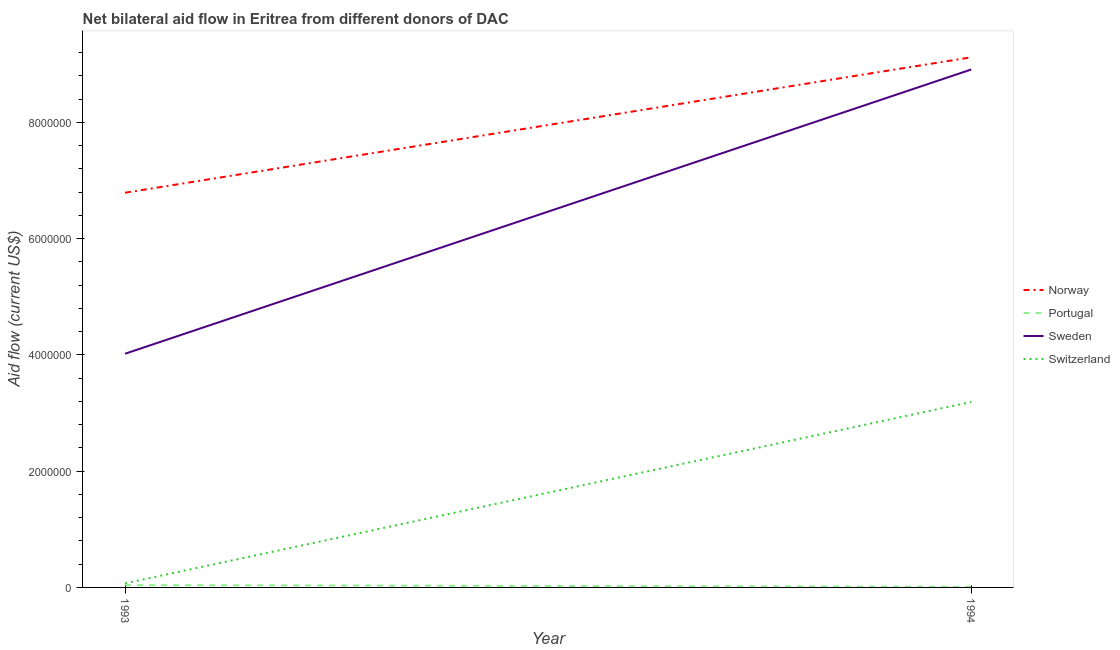How many different coloured lines are there?
Make the answer very short. 4. Does the line corresponding to amount of aid given by norway intersect with the line corresponding to amount of aid given by portugal?
Keep it short and to the point. No. What is the amount of aid given by switzerland in 1994?
Offer a very short reply. 3.19e+06. Across all years, what is the maximum amount of aid given by norway?
Your response must be concise. 9.12e+06. Across all years, what is the minimum amount of aid given by sweden?
Give a very brief answer. 4.02e+06. In which year was the amount of aid given by sweden maximum?
Your answer should be compact. 1994. What is the total amount of aid given by portugal in the graph?
Your answer should be very brief. 5.00e+04. What is the difference between the amount of aid given by switzerland in 1993 and that in 1994?
Provide a succinct answer. -3.12e+06. What is the difference between the amount of aid given by portugal in 1993 and the amount of aid given by sweden in 1994?
Make the answer very short. -8.87e+06. What is the average amount of aid given by norway per year?
Offer a very short reply. 7.96e+06. In the year 1993, what is the difference between the amount of aid given by portugal and amount of aid given by sweden?
Your response must be concise. -3.98e+06. In how many years, is the amount of aid given by portugal greater than 5600000 US$?
Offer a very short reply. 0. What is the ratio of the amount of aid given by switzerland in 1993 to that in 1994?
Give a very brief answer. 0.02. Is the amount of aid given by norway strictly greater than the amount of aid given by switzerland over the years?
Give a very brief answer. Yes. How many lines are there?
Your answer should be very brief. 4. Does the graph contain any zero values?
Offer a very short reply. No. Does the graph contain grids?
Offer a very short reply. No. Where does the legend appear in the graph?
Your answer should be very brief. Center right. How are the legend labels stacked?
Your response must be concise. Vertical. What is the title of the graph?
Offer a very short reply. Net bilateral aid flow in Eritrea from different donors of DAC. Does "UNTA" appear as one of the legend labels in the graph?
Make the answer very short. No. What is the label or title of the X-axis?
Your answer should be very brief. Year. What is the label or title of the Y-axis?
Give a very brief answer. Aid flow (current US$). What is the Aid flow (current US$) in Norway in 1993?
Provide a short and direct response. 6.79e+06. What is the Aid flow (current US$) in Portugal in 1993?
Make the answer very short. 4.00e+04. What is the Aid flow (current US$) in Sweden in 1993?
Give a very brief answer. 4.02e+06. What is the Aid flow (current US$) in Norway in 1994?
Your response must be concise. 9.12e+06. What is the Aid flow (current US$) of Portugal in 1994?
Your answer should be very brief. 10000. What is the Aid flow (current US$) of Sweden in 1994?
Offer a very short reply. 8.91e+06. What is the Aid flow (current US$) of Switzerland in 1994?
Offer a terse response. 3.19e+06. Across all years, what is the maximum Aid flow (current US$) of Norway?
Your answer should be very brief. 9.12e+06. Across all years, what is the maximum Aid flow (current US$) of Sweden?
Provide a short and direct response. 8.91e+06. Across all years, what is the maximum Aid flow (current US$) in Switzerland?
Keep it short and to the point. 3.19e+06. Across all years, what is the minimum Aid flow (current US$) in Norway?
Ensure brevity in your answer.  6.79e+06. Across all years, what is the minimum Aid flow (current US$) of Sweden?
Offer a very short reply. 4.02e+06. Across all years, what is the minimum Aid flow (current US$) in Switzerland?
Make the answer very short. 7.00e+04. What is the total Aid flow (current US$) in Norway in the graph?
Offer a very short reply. 1.59e+07. What is the total Aid flow (current US$) in Portugal in the graph?
Your response must be concise. 5.00e+04. What is the total Aid flow (current US$) of Sweden in the graph?
Keep it short and to the point. 1.29e+07. What is the total Aid flow (current US$) in Switzerland in the graph?
Provide a short and direct response. 3.26e+06. What is the difference between the Aid flow (current US$) of Norway in 1993 and that in 1994?
Give a very brief answer. -2.33e+06. What is the difference between the Aid flow (current US$) of Sweden in 1993 and that in 1994?
Keep it short and to the point. -4.89e+06. What is the difference between the Aid flow (current US$) of Switzerland in 1993 and that in 1994?
Offer a very short reply. -3.12e+06. What is the difference between the Aid flow (current US$) of Norway in 1993 and the Aid flow (current US$) of Portugal in 1994?
Your answer should be compact. 6.78e+06. What is the difference between the Aid flow (current US$) of Norway in 1993 and the Aid flow (current US$) of Sweden in 1994?
Give a very brief answer. -2.12e+06. What is the difference between the Aid flow (current US$) in Norway in 1993 and the Aid flow (current US$) in Switzerland in 1994?
Your answer should be very brief. 3.60e+06. What is the difference between the Aid flow (current US$) in Portugal in 1993 and the Aid flow (current US$) in Sweden in 1994?
Keep it short and to the point. -8.87e+06. What is the difference between the Aid flow (current US$) in Portugal in 1993 and the Aid flow (current US$) in Switzerland in 1994?
Make the answer very short. -3.15e+06. What is the difference between the Aid flow (current US$) of Sweden in 1993 and the Aid flow (current US$) of Switzerland in 1994?
Keep it short and to the point. 8.30e+05. What is the average Aid flow (current US$) in Norway per year?
Offer a terse response. 7.96e+06. What is the average Aid flow (current US$) in Portugal per year?
Your answer should be compact. 2.50e+04. What is the average Aid flow (current US$) in Sweden per year?
Give a very brief answer. 6.46e+06. What is the average Aid flow (current US$) in Switzerland per year?
Offer a terse response. 1.63e+06. In the year 1993, what is the difference between the Aid flow (current US$) in Norway and Aid flow (current US$) in Portugal?
Offer a very short reply. 6.75e+06. In the year 1993, what is the difference between the Aid flow (current US$) of Norway and Aid flow (current US$) of Sweden?
Keep it short and to the point. 2.77e+06. In the year 1993, what is the difference between the Aid flow (current US$) in Norway and Aid flow (current US$) in Switzerland?
Your answer should be very brief. 6.72e+06. In the year 1993, what is the difference between the Aid flow (current US$) in Portugal and Aid flow (current US$) in Sweden?
Your answer should be compact. -3.98e+06. In the year 1993, what is the difference between the Aid flow (current US$) of Portugal and Aid flow (current US$) of Switzerland?
Give a very brief answer. -3.00e+04. In the year 1993, what is the difference between the Aid flow (current US$) in Sweden and Aid flow (current US$) in Switzerland?
Your response must be concise. 3.95e+06. In the year 1994, what is the difference between the Aid flow (current US$) of Norway and Aid flow (current US$) of Portugal?
Your answer should be compact. 9.11e+06. In the year 1994, what is the difference between the Aid flow (current US$) of Norway and Aid flow (current US$) of Switzerland?
Your answer should be compact. 5.93e+06. In the year 1994, what is the difference between the Aid flow (current US$) in Portugal and Aid flow (current US$) in Sweden?
Provide a succinct answer. -8.90e+06. In the year 1994, what is the difference between the Aid flow (current US$) of Portugal and Aid flow (current US$) of Switzerland?
Provide a succinct answer. -3.18e+06. In the year 1994, what is the difference between the Aid flow (current US$) of Sweden and Aid flow (current US$) of Switzerland?
Your answer should be compact. 5.72e+06. What is the ratio of the Aid flow (current US$) in Norway in 1993 to that in 1994?
Offer a terse response. 0.74. What is the ratio of the Aid flow (current US$) of Portugal in 1993 to that in 1994?
Your answer should be very brief. 4. What is the ratio of the Aid flow (current US$) of Sweden in 1993 to that in 1994?
Your answer should be compact. 0.45. What is the ratio of the Aid flow (current US$) in Switzerland in 1993 to that in 1994?
Your answer should be compact. 0.02. What is the difference between the highest and the second highest Aid flow (current US$) in Norway?
Offer a terse response. 2.33e+06. What is the difference between the highest and the second highest Aid flow (current US$) in Portugal?
Make the answer very short. 3.00e+04. What is the difference between the highest and the second highest Aid flow (current US$) of Sweden?
Offer a very short reply. 4.89e+06. What is the difference between the highest and the second highest Aid flow (current US$) of Switzerland?
Provide a short and direct response. 3.12e+06. What is the difference between the highest and the lowest Aid flow (current US$) in Norway?
Give a very brief answer. 2.33e+06. What is the difference between the highest and the lowest Aid flow (current US$) of Portugal?
Your answer should be very brief. 3.00e+04. What is the difference between the highest and the lowest Aid flow (current US$) of Sweden?
Your answer should be very brief. 4.89e+06. What is the difference between the highest and the lowest Aid flow (current US$) in Switzerland?
Your answer should be very brief. 3.12e+06. 